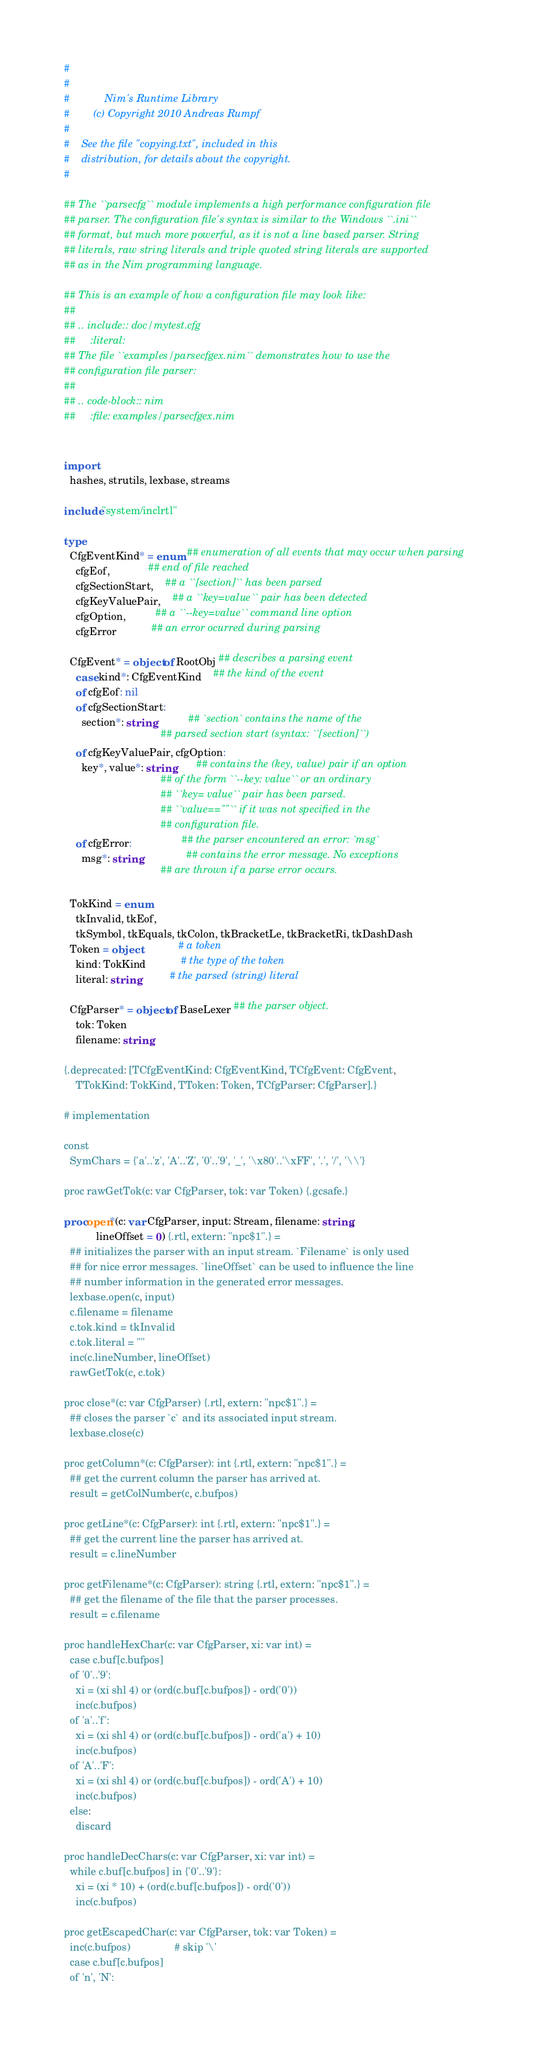Convert code to text. <code><loc_0><loc_0><loc_500><loc_500><_Nim_>#
#
#            Nim's Runtime Library
#        (c) Copyright 2010 Andreas Rumpf
#
#    See the file "copying.txt", included in this
#    distribution, for details about the copyright.
#

## The ``parsecfg`` module implements a high performance configuration file 
## parser. The configuration file's syntax is similar to the Windows ``.ini`` 
## format, but much more powerful, as it is not a line based parser. String 
## literals, raw string literals and triple quoted string literals are supported 
## as in the Nim programming language.

## This is an example of how a configuration file may look like:
##
## .. include:: doc/mytest.cfg
##     :literal:
## The file ``examples/parsecfgex.nim`` demonstrates how to use the 
## configuration file parser:
##
## .. code-block:: nim
##     :file: examples/parsecfgex.nim


import
  hashes, strutils, lexbase, streams

include "system/inclrtl"

type
  CfgEventKind* = enum ## enumeration of all events that may occur when parsing
    cfgEof,             ## end of file reached
    cfgSectionStart,    ## a ``[section]`` has been parsed
    cfgKeyValuePair,    ## a ``key=value`` pair has been detected
    cfgOption,          ## a ``--key=value`` command line option
    cfgError            ## an error ocurred during parsing
    
  CfgEvent* = object of RootObj ## describes a parsing event
    case kind*: CfgEventKind    ## the kind of the event
    of cfgEof: nil
    of cfgSectionStart: 
      section*: string           ## `section` contains the name of the 
                                 ## parsed section start (syntax: ``[section]``)
    of cfgKeyValuePair, cfgOption: 
      key*, value*: string       ## contains the (key, value) pair if an option
                                 ## of the form ``--key: value`` or an ordinary
                                 ## ``key= value`` pair has been parsed.
                                 ## ``value==""`` if it was not specified in the
                                 ## configuration file.
    of cfgError:                 ## the parser encountered an error: `msg`
      msg*: string               ## contains the error message. No exceptions
                                 ## are thrown if a parse error occurs.
  
  TokKind = enum 
    tkInvalid, tkEof,        
    tkSymbol, tkEquals, tkColon, tkBracketLe, tkBracketRi, tkDashDash
  Token = object             # a token
    kind: TokKind            # the type of the token
    literal: string          # the parsed (string) literal
  
  CfgParser* = object of BaseLexer ## the parser object.
    tok: Token
    filename: string

{.deprecated: [TCfgEventKind: CfgEventKind, TCfgEvent: CfgEvent,
    TTokKind: TokKind, TToken: Token, TCfgParser: CfgParser].}

# implementation

const 
  SymChars = {'a'..'z', 'A'..'Z', '0'..'9', '_', '\x80'..'\xFF', '.', '/', '\\'} 
  
proc rawGetTok(c: var CfgParser, tok: var Token) {.gcsafe.}

proc open*(c: var CfgParser, input: Stream, filename: string, 
           lineOffset = 0) {.rtl, extern: "npc$1".} =
  ## initializes the parser with an input stream. `Filename` is only used
  ## for nice error messages. `lineOffset` can be used to influence the line
  ## number information in the generated error messages.
  lexbase.open(c, input)
  c.filename = filename
  c.tok.kind = tkInvalid
  c.tok.literal = ""
  inc(c.lineNumber, lineOffset)
  rawGetTok(c, c.tok)
  
proc close*(c: var CfgParser) {.rtl, extern: "npc$1".} =
  ## closes the parser `c` and its associated input stream.
  lexbase.close(c)

proc getColumn*(c: CfgParser): int {.rtl, extern: "npc$1".} =
  ## get the current column the parser has arrived at.
  result = getColNumber(c, c.bufpos)

proc getLine*(c: CfgParser): int {.rtl, extern: "npc$1".} =
  ## get the current line the parser has arrived at.
  result = c.lineNumber

proc getFilename*(c: CfgParser): string {.rtl, extern: "npc$1".} =
  ## get the filename of the file that the parser processes.
  result = c.filename

proc handleHexChar(c: var CfgParser, xi: var int) = 
  case c.buf[c.bufpos]
  of '0'..'9': 
    xi = (xi shl 4) or (ord(c.buf[c.bufpos]) - ord('0'))
    inc(c.bufpos)
  of 'a'..'f': 
    xi = (xi shl 4) or (ord(c.buf[c.bufpos]) - ord('a') + 10)
    inc(c.bufpos)
  of 'A'..'F': 
    xi = (xi shl 4) or (ord(c.buf[c.bufpos]) - ord('A') + 10)
    inc(c.bufpos)
  else: 
    discard

proc handleDecChars(c: var CfgParser, xi: var int) = 
  while c.buf[c.bufpos] in {'0'..'9'}: 
    xi = (xi * 10) + (ord(c.buf[c.bufpos]) - ord('0'))
    inc(c.bufpos)

proc getEscapedChar(c: var CfgParser, tok: var Token) = 
  inc(c.bufpos)               # skip '\'
  case c.buf[c.bufpos]
  of 'n', 'N': </code> 